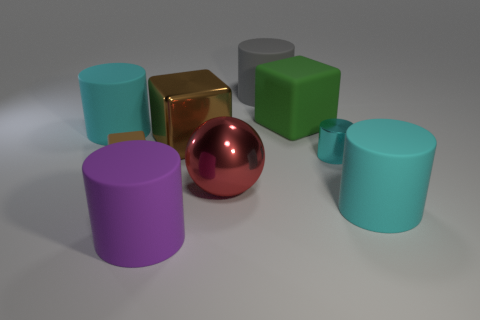Which objects are metallic and which are matte in appearance? Within this collection of objects, the red sphere and the gold cube stand out with a reflective, metallic sheen, while the remaining items exhibit a matte finish, which absorbs light and prevents reflection. Is there a pattern to the arrangement of these objects? The objects seem to be arranged with no specific pattern in mind. They are placed such that we see a mix of different shapes and colors, perhaps suggesting a randomized or organic distribution as opposed to a deliberate pattern. 